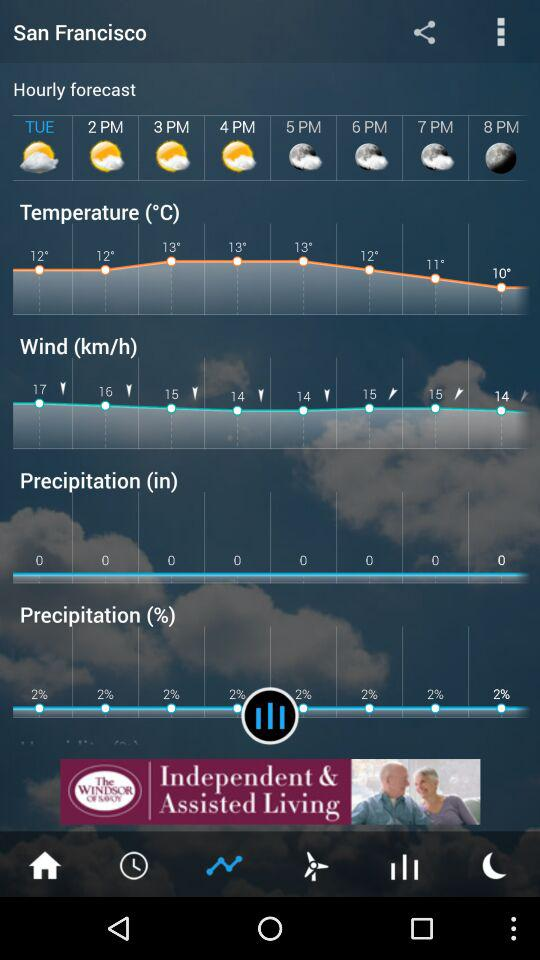What is the maximum win speed?
When the provided information is insufficient, respond with <no answer>. <no answer> 